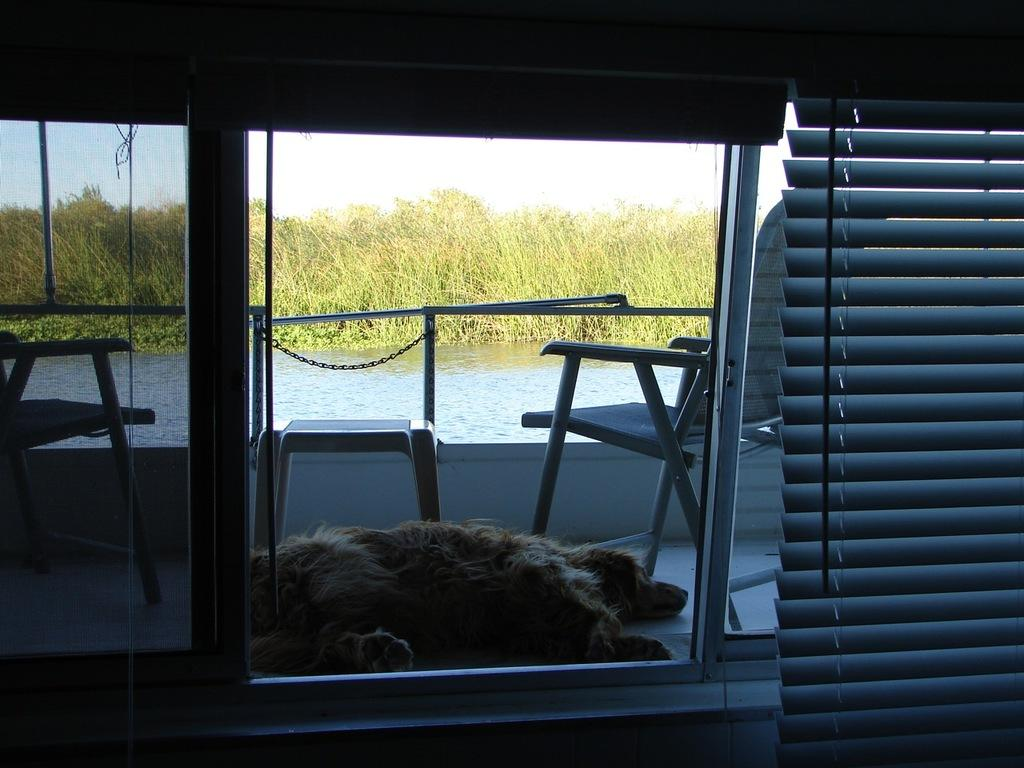What type of openings can be seen in the image? There are windows in the image. What is used to control the amount of light entering the windows? Window blinds are present in the image. What type of furniture is visible in the image? There are chairs in the image. What type of animal is present in the image? There is a dog in the image. What natural element is visible in the image? Water and grass are present in the image. What is the weight of the yak in the image? There is no yak present in the image, so its weight cannot be determined. How many snakes are slithering on the grass in the image? There are no snakes present in the image; only a dog, chairs, windows, window blinds, water, and grass can be seen. 